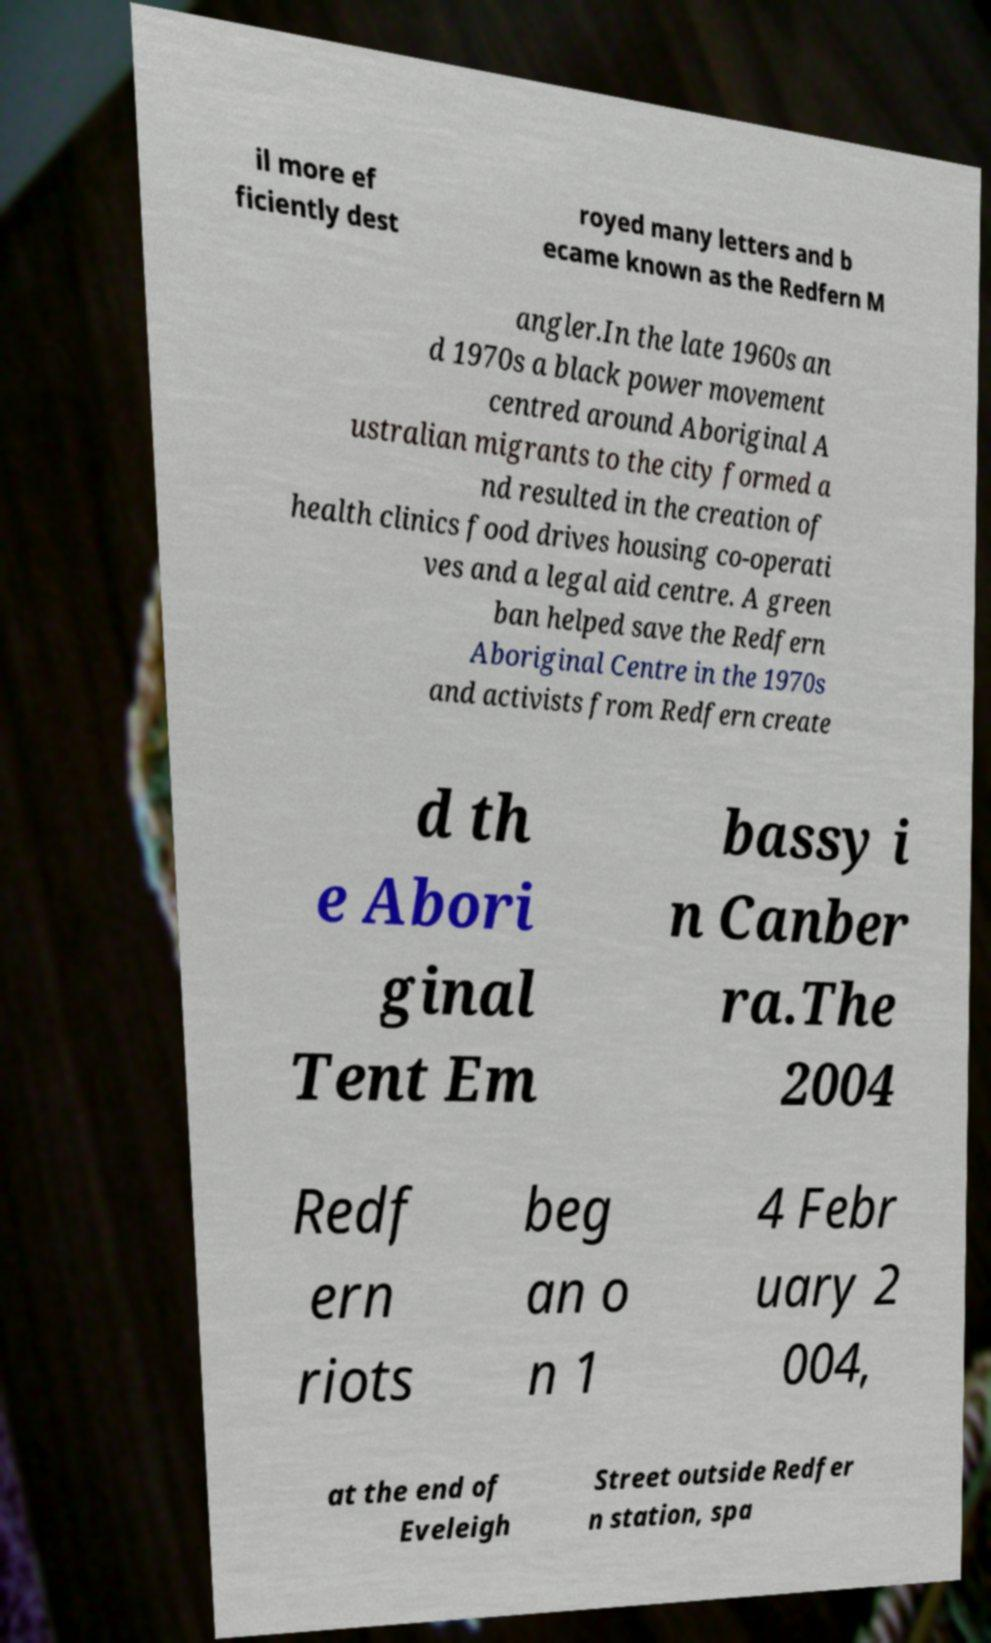I need the written content from this picture converted into text. Can you do that? il more ef ficiently dest royed many letters and b ecame known as the Redfern M angler.In the late 1960s an d 1970s a black power movement centred around Aboriginal A ustralian migrants to the city formed a nd resulted in the creation of health clinics food drives housing co-operati ves and a legal aid centre. A green ban helped save the Redfern Aboriginal Centre in the 1970s and activists from Redfern create d th e Abori ginal Tent Em bassy i n Canber ra.The 2004 Redf ern riots beg an o n 1 4 Febr uary 2 004, at the end of Eveleigh Street outside Redfer n station, spa 